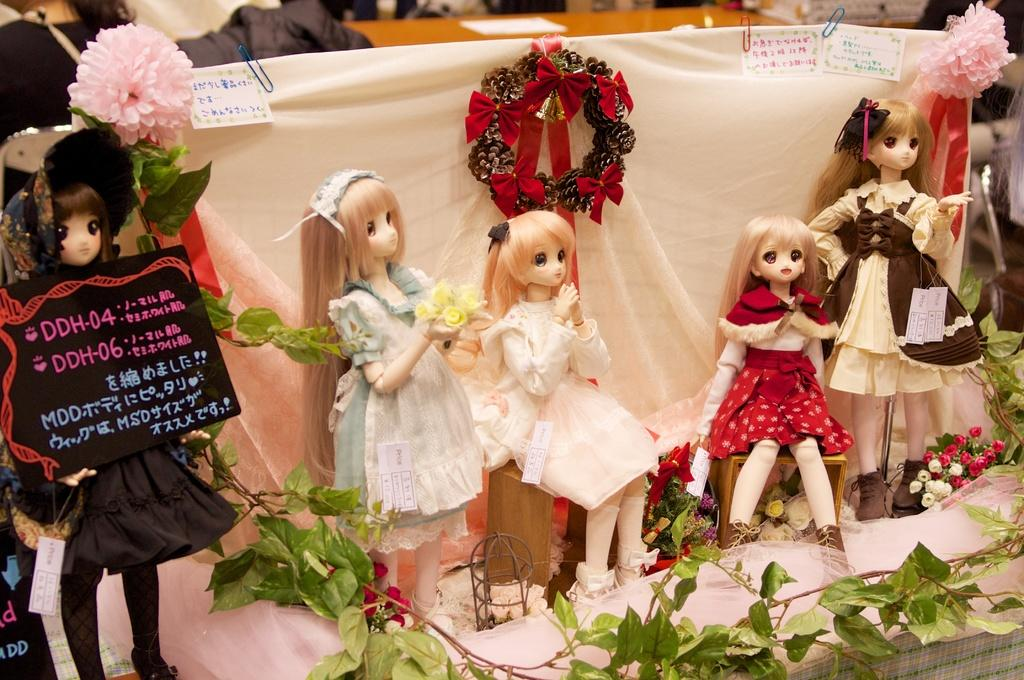What type of objects can be seen in the image? There are dolls, a board, papers, paper clips, flowers, plants, cloth, and a wreath in the image. What is the board used for in the image? The purpose of the board in the image is not specified, but it could be used for displaying or organizing the papers and other items. What might be used to hold the papers together in the image? Paper clips are present in the image, which might be used to hold the papers together. What type of decorative items are present in the image? Flowers, a wreath, and possibly the cloth can be considered decorative items in the image. What other objects can be seen in the image? There are other objects in the image, but their specific nature is not mentioned in the provided facts. Where is the uncle sitting with his umbrella in the image? There is no uncle or umbrella present in the image. What type of religious ceremony is taking place in the image? There is no indication of a religious ceremony or a church in the image. 